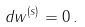Convert formula to latex. <formula><loc_0><loc_0><loc_500><loc_500>d w ^ { ( s ) } = 0 \, .</formula> 